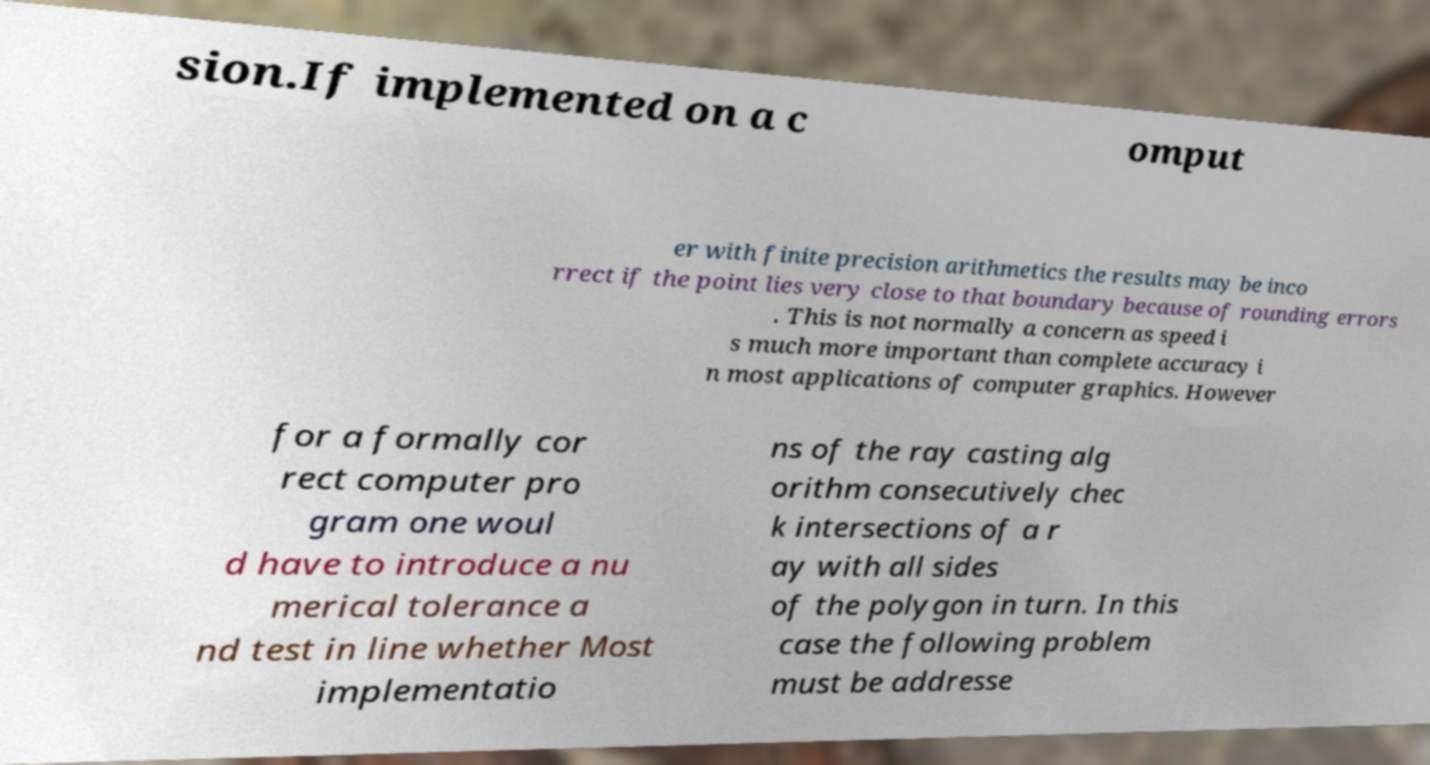Could you assist in decoding the text presented in this image and type it out clearly? sion.If implemented on a c omput er with finite precision arithmetics the results may be inco rrect if the point lies very close to that boundary because of rounding errors . This is not normally a concern as speed i s much more important than complete accuracy i n most applications of computer graphics. However for a formally cor rect computer pro gram one woul d have to introduce a nu merical tolerance a nd test in line whether Most implementatio ns of the ray casting alg orithm consecutively chec k intersections of a r ay with all sides of the polygon in turn. In this case the following problem must be addresse 